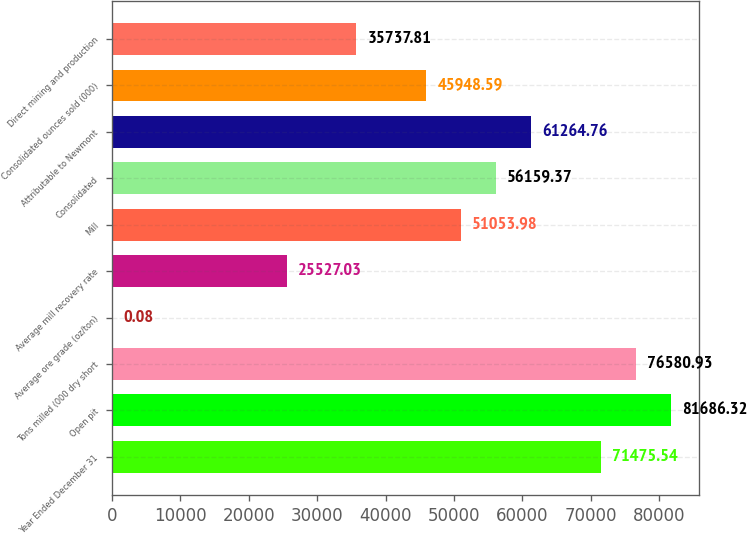Convert chart. <chart><loc_0><loc_0><loc_500><loc_500><bar_chart><fcel>Year Ended December 31<fcel>Open pit<fcel>Tons milled (000 dry short<fcel>Average ore grade (oz/ton)<fcel>Average mill recovery rate<fcel>Mill<fcel>Consolidated<fcel>Attributable to Newmont<fcel>Consolidated ounces sold (000)<fcel>Direct mining and production<nl><fcel>71475.5<fcel>81686.3<fcel>76580.9<fcel>0.08<fcel>25527<fcel>51054<fcel>56159.4<fcel>61264.8<fcel>45948.6<fcel>35737.8<nl></chart> 